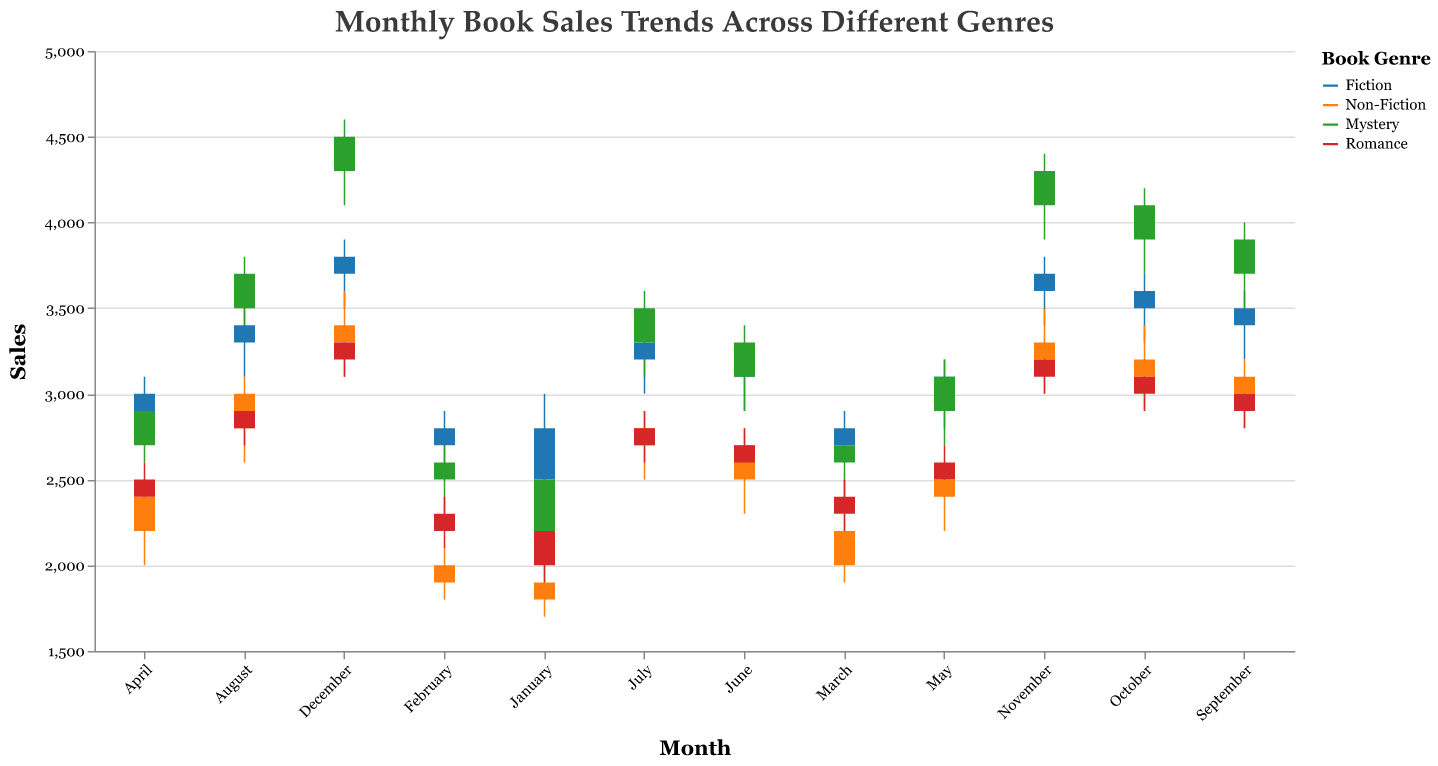What's the title of the figure? The title of the figure is typically found at the top and often summarizes the content of the plot. In this case, it reads "Monthly Book Sales Trends Across Different Genres".
Answer: Monthly Book Sales Trends Across Different Genres Which genre had the highest sales in December? Looking at December, you see the highest point in the candlestick plot is 4600. This corresponds to the Mystery genre.
Answer: Mystery How did Fiction book sales change from January to December? Fiction book sales opened at 2500 in January and ended at 3800 in December, showing a general increase throughout the year.
Answer: Increased For August, which genre had the smallest difference between the high and low sales values? In August, the differences are calculated as follows: Fiction (3500-3100=400), Non-Fiction (3100-2600=500), Mystery (3800-3300=500), and Romance (3000-2700=300). Thus, the smallest difference is for Romance.
Answer: Romance Which month shows the highest closing sales for Romance novels? You need to look at the Romance closing sales for each month and identify the highest. Romance closes at 2800 in July, which is the highest.
Answer: July Compare the highest sales points of Fiction and Mystery genres in April. Which genre peaked higher, and by how much? In April, Fiction peaked at 3100 while Mystery peaked at 3000. The difference is calculated as 3100-3000=100, showing that Fiction peaked higher by 100.
Answer: Fiction by 100 What month saw the lowest opening sales for Non-Fiction? To find the lowest opening sales for Non-Fiction, examine each month's opening sales and find the minimum. The lowest is in January at 1800.
Answer: January How did Mystery sales perform in the third quarter (July to September) in terms of opening values? The opening values for Mystery in the third quarter are: July (3300), August (3500), September (3700). They show a steady increase each month.
Answer: Increased Which genre and month show the highest overall sales point on the chart? The highest overall sales point is 4600, shown by the Mystery genre in December.
Answer: Mystery in December 